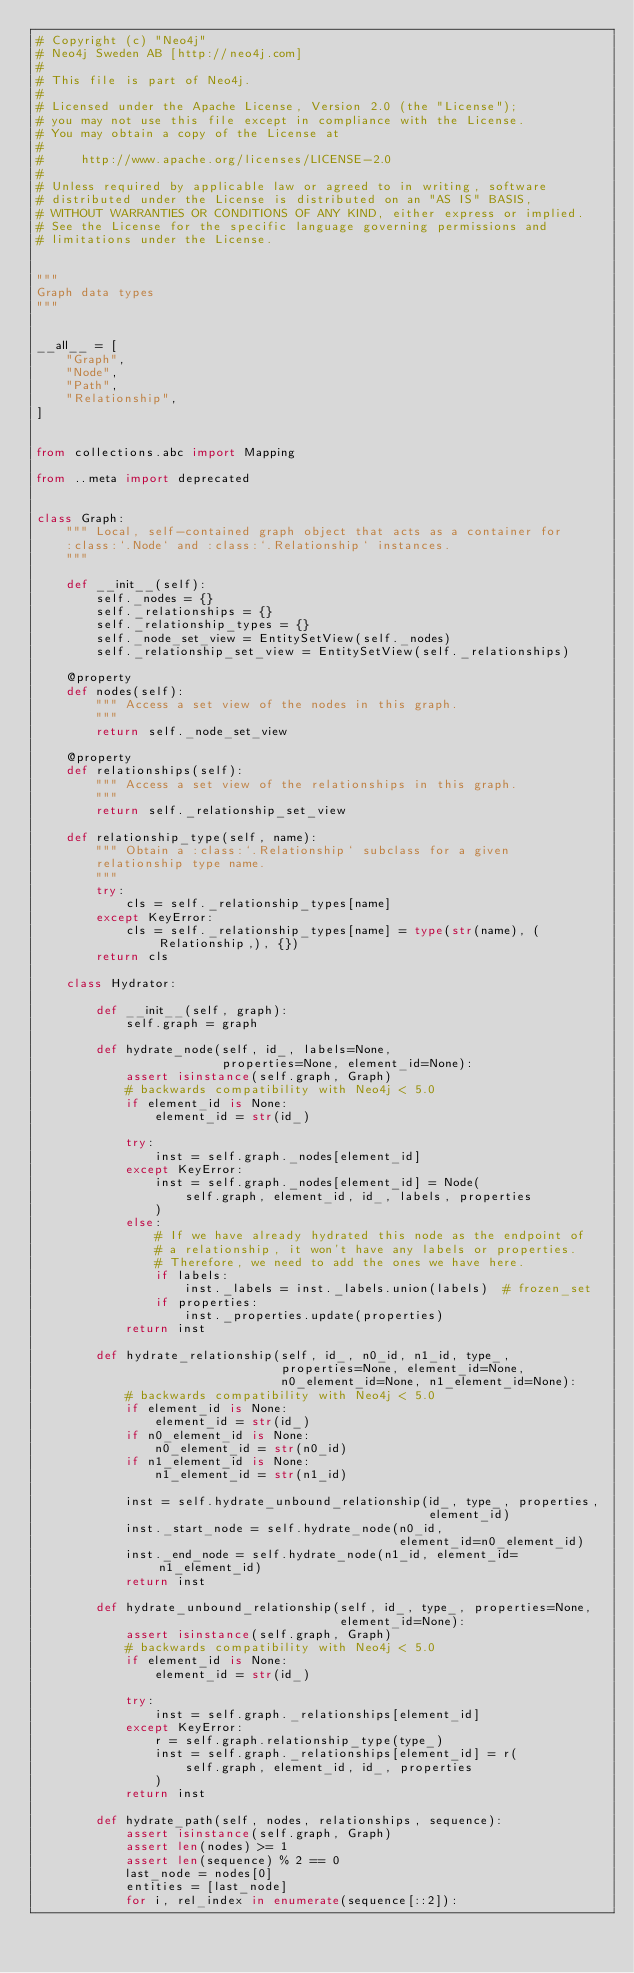Convert code to text. <code><loc_0><loc_0><loc_500><loc_500><_Python_># Copyright (c) "Neo4j"
# Neo4j Sweden AB [http://neo4j.com]
#
# This file is part of Neo4j.
#
# Licensed under the Apache License, Version 2.0 (the "License");
# you may not use this file except in compliance with the License.
# You may obtain a copy of the License at
#
#     http://www.apache.org/licenses/LICENSE-2.0
#
# Unless required by applicable law or agreed to in writing, software
# distributed under the License is distributed on an "AS IS" BASIS,
# WITHOUT WARRANTIES OR CONDITIONS OF ANY KIND, either express or implied.
# See the License for the specific language governing permissions and
# limitations under the License.


"""
Graph data types
"""


__all__ = [
    "Graph",
    "Node",
    "Path",
    "Relationship",
]


from collections.abc import Mapping

from ..meta import deprecated


class Graph:
    """ Local, self-contained graph object that acts as a container for
    :class:`.Node` and :class:`.Relationship` instances.
    """

    def __init__(self):
        self._nodes = {}
        self._relationships = {}
        self._relationship_types = {}
        self._node_set_view = EntitySetView(self._nodes)
        self._relationship_set_view = EntitySetView(self._relationships)

    @property
    def nodes(self):
        """ Access a set view of the nodes in this graph.
        """
        return self._node_set_view

    @property
    def relationships(self):
        """ Access a set view of the relationships in this graph.
        """
        return self._relationship_set_view

    def relationship_type(self, name):
        """ Obtain a :class:`.Relationship` subclass for a given
        relationship type name.
        """
        try:
            cls = self._relationship_types[name]
        except KeyError:
            cls = self._relationship_types[name] = type(str(name), (Relationship,), {})
        return cls

    class Hydrator:

        def __init__(self, graph):
            self.graph = graph

        def hydrate_node(self, id_, labels=None,
                         properties=None, element_id=None):
            assert isinstance(self.graph, Graph)
            # backwards compatibility with Neo4j < 5.0
            if element_id is None:
                element_id = str(id_)

            try:
                inst = self.graph._nodes[element_id]
            except KeyError:
                inst = self.graph._nodes[element_id] = Node(
                    self.graph, element_id, id_, labels, properties
                )
            else:
                # If we have already hydrated this node as the endpoint of
                # a relationship, it won't have any labels or properties.
                # Therefore, we need to add the ones we have here.
                if labels:
                    inst._labels = inst._labels.union(labels)  # frozen_set
                if properties:
                    inst._properties.update(properties)
            return inst

        def hydrate_relationship(self, id_, n0_id, n1_id, type_,
                                 properties=None, element_id=None,
                                 n0_element_id=None, n1_element_id=None):
            # backwards compatibility with Neo4j < 5.0
            if element_id is None:
                element_id = str(id_)
            if n0_element_id is None:
                n0_element_id = str(n0_id)
            if n1_element_id is None:
                n1_element_id = str(n1_id)

            inst = self.hydrate_unbound_relationship(id_, type_, properties,
                                                     element_id)
            inst._start_node = self.hydrate_node(n0_id,
                                                 element_id=n0_element_id)
            inst._end_node = self.hydrate_node(n1_id, element_id=n1_element_id)
            return inst

        def hydrate_unbound_relationship(self, id_, type_, properties=None,
                                         element_id=None):
            assert isinstance(self.graph, Graph)
            # backwards compatibility with Neo4j < 5.0
            if element_id is None:
                element_id = str(id_)

            try:
                inst = self.graph._relationships[element_id]
            except KeyError:
                r = self.graph.relationship_type(type_)
                inst = self.graph._relationships[element_id] = r(
                    self.graph, element_id, id_, properties
                )
            return inst

        def hydrate_path(self, nodes, relationships, sequence):
            assert isinstance(self.graph, Graph)
            assert len(nodes) >= 1
            assert len(sequence) % 2 == 0
            last_node = nodes[0]
            entities = [last_node]
            for i, rel_index in enumerate(sequence[::2]):</code> 